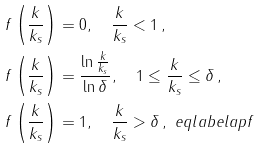Convert formula to latex. <formula><loc_0><loc_0><loc_500><loc_500>& f \left ( \frac { k } { k _ { s } } \right ) = 0 , \quad \frac { k } { k _ { s } } < 1 \, , \\ & f \left ( \frac { k } { k _ { s } } \right ) = \frac { \ln \frac { k } { k _ { s } } } { \ln \delta } , \quad 1 \leq \frac { k } { k _ { s } } \leq \delta \, , \\ & f \left ( \frac { k } { k _ { s } } \right ) = 1 , \quad \frac { k } { k _ { s } } > \delta \, , \ e q l a b e l { a p f }</formula> 